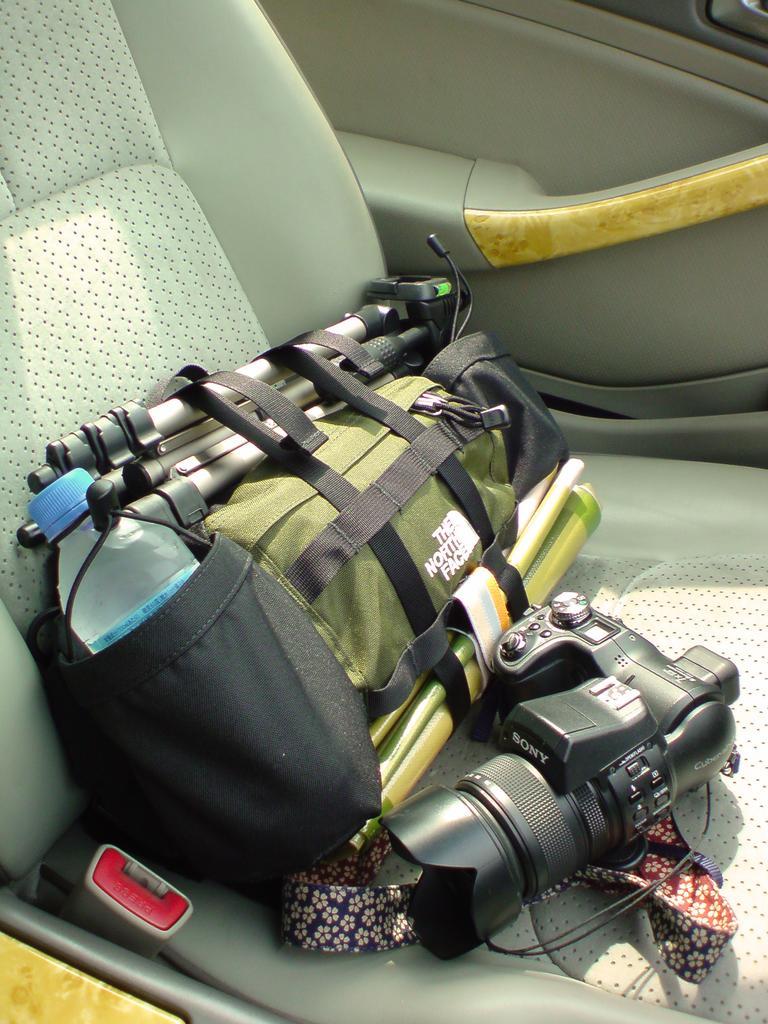Please provide a concise description of this image. In this picture I can observe digital camera, tripod stand and bag in the vehicle. In the background I can observe door of a vehicle. 